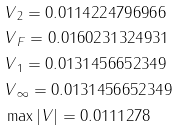<formula> <loc_0><loc_0><loc_500><loc_500>& \| V \| _ { 2 } = 0 . 0 1 1 4 2 2 4 7 9 6 9 6 6 \\ & \| V \| _ { F } = 0 . 0 1 6 0 2 3 1 3 2 4 9 3 1 \\ & \| V \| _ { 1 } = 0 . 0 1 3 1 4 5 6 6 5 2 3 4 9 \\ & \| V \| _ { \infty } = 0 . 0 1 3 1 4 5 6 6 5 2 3 4 9 \\ & \max | V | = 0 . 0 1 1 1 2 7 8</formula> 